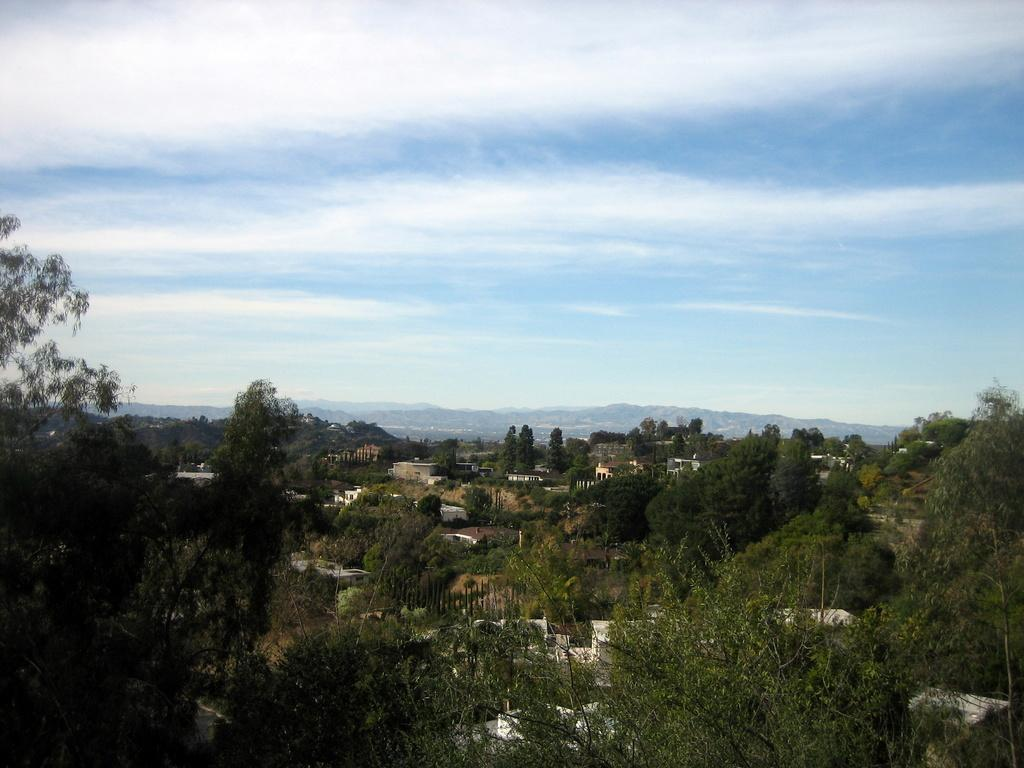What type of natural elements can be seen in the image? There are many trees in the image. What type of man-made structures are present in the image? There are buildings in the image. What can be seen in the background of the image? The sky is visible in the background of the image. What is the condition of the sky in the image? There are clouds in the sky. What type of machine is being used to cut the lumber in the image? There is no machine or lumber present in the image; it features trees and buildings. 